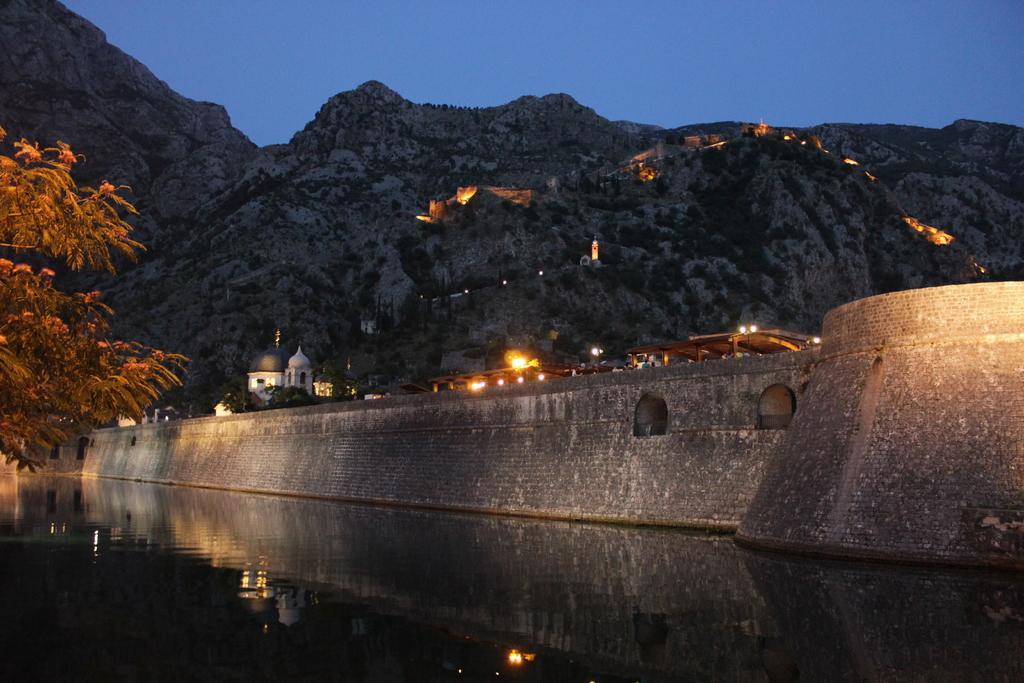Could you give a brief overview of what you see in this image? In the foreground of this image, there is water. On the left, there is a tree. In the background, there is a bridge, few buildings, lights, mountains and the sky. 